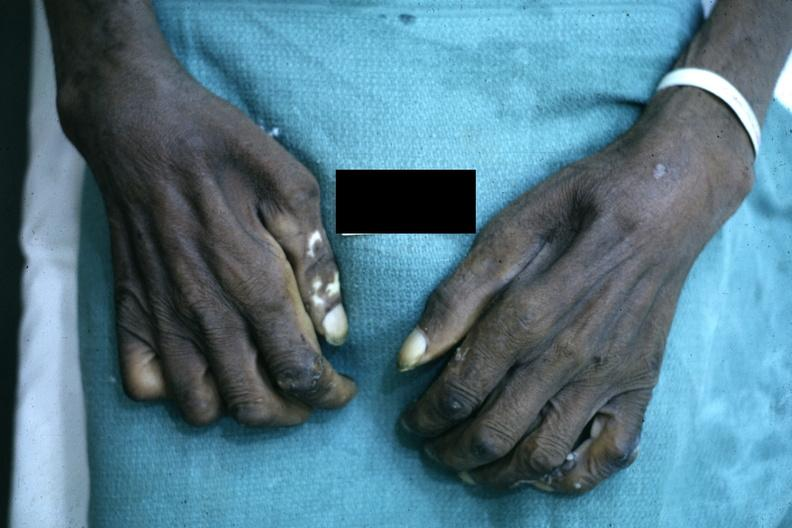what is present?
Answer the question using a single word or phrase. Hand 